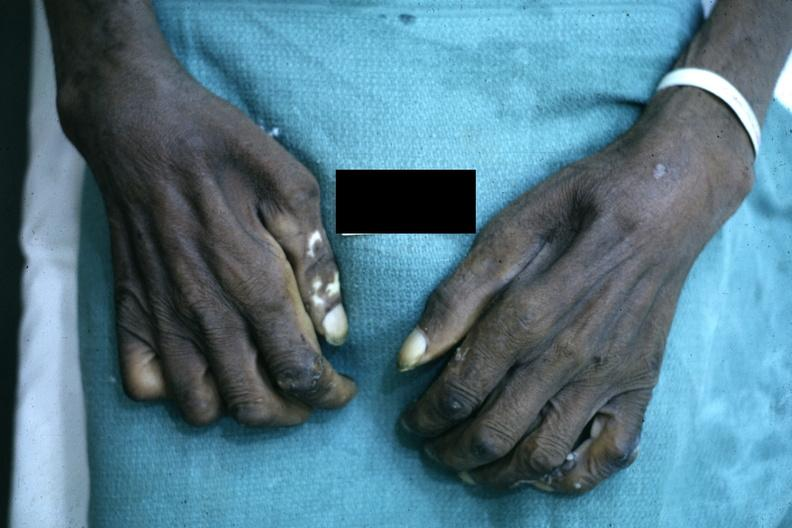what is present?
Answer the question using a single word or phrase. Hand 